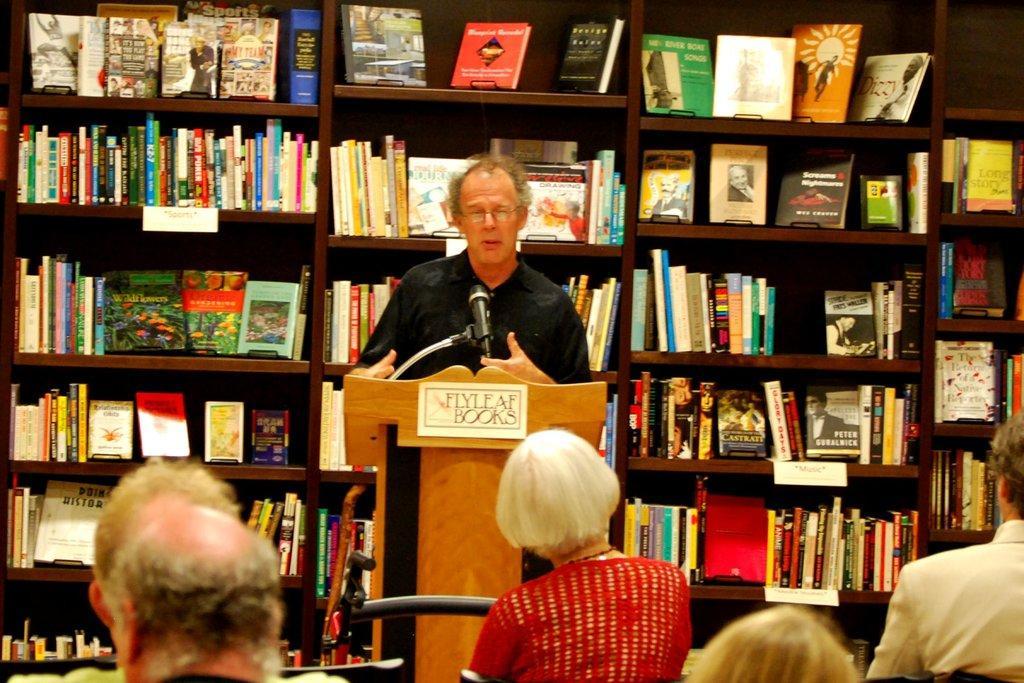How would you summarize this image in a sentence or two? In this picture we can see a man standing in front of a podium, there is a microphone here, in the background there is a rack, we can see some books on the rack, we can see some people sitting in the front. 